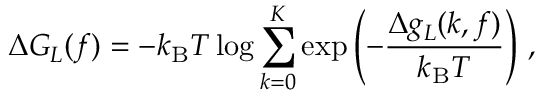<formula> <loc_0><loc_0><loc_500><loc_500>\Delta G _ { L } ( f ) = - k _ { B } T \log \sum _ { k = 0 } ^ { K } \exp \left ( - \frac { \Delta g _ { L } ( k , f ) } { k _ { B } T } \right ) \, ,</formula> 